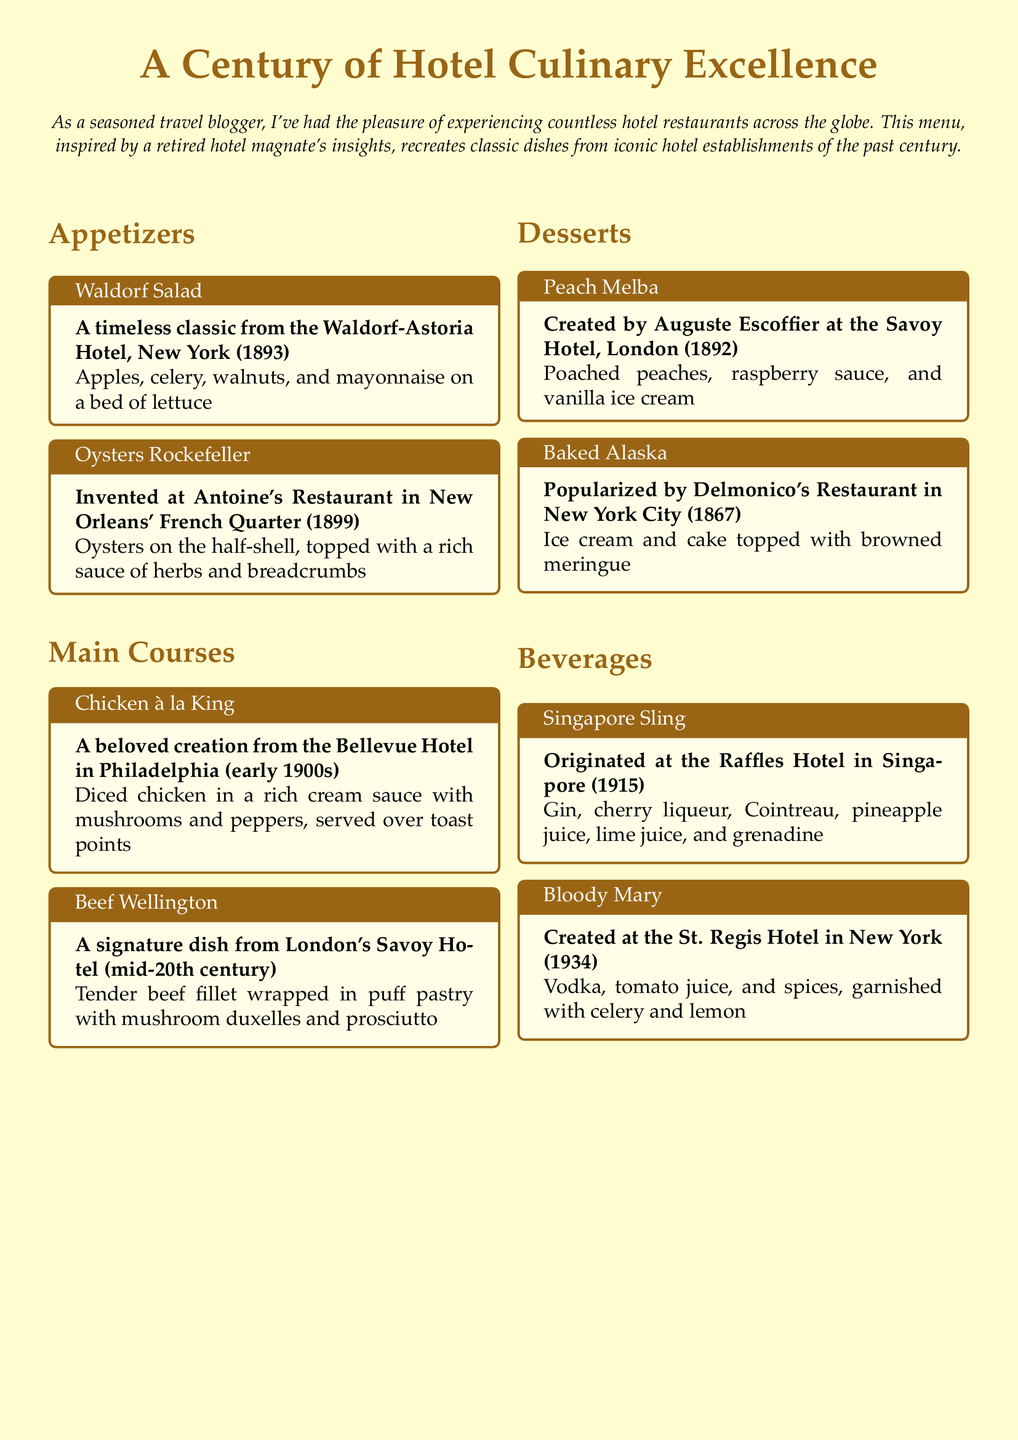What is the title of the menu? The title of the menu is presented at the top of the document, which highlights its theme.
Answer: A Century of Hotel Culinary Excellence Which hotel is famous for the Waldorf Salad? The Waldorf Salad is a classic dish from a specific hotel, noted in the appetizers section.
Answer: Waldorf-Astoria Hotel, New York In which year was Oysters Rockefeller invented? The document provides the year when Oysters Rockefeller was created, according to its historical context.
Answer: 1899 What is the main ingredient in Chicken à la King? The main ingredient of Chicken à la King is specified in the description located under the main courses section.
Answer: Diced chicken Which drink was created at the St. Regis Hotel? This question references the beverages section, where specific drinks are associated with their origins.
Answer: Bloody Mary What type of dessert is served as Peach Melba? The type of dessert is indicated in the desserts section, where it's specifically categorized.
Answer: Dessert Where did the Singapore Sling originate? The origin of the Singapore Sling is given within the beverage descriptions, explaining its historical background.
Answer: Raffles Hotel, Singapore What year did Baked Alaska become popular? The year that Baked Alaska became popular is mentioned in its historical context under the desserts section.
Answer: 1867 